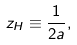Convert formula to latex. <formula><loc_0><loc_0><loc_500><loc_500>z _ { H } \equiv \frac { 1 } { 2 a } ,</formula> 